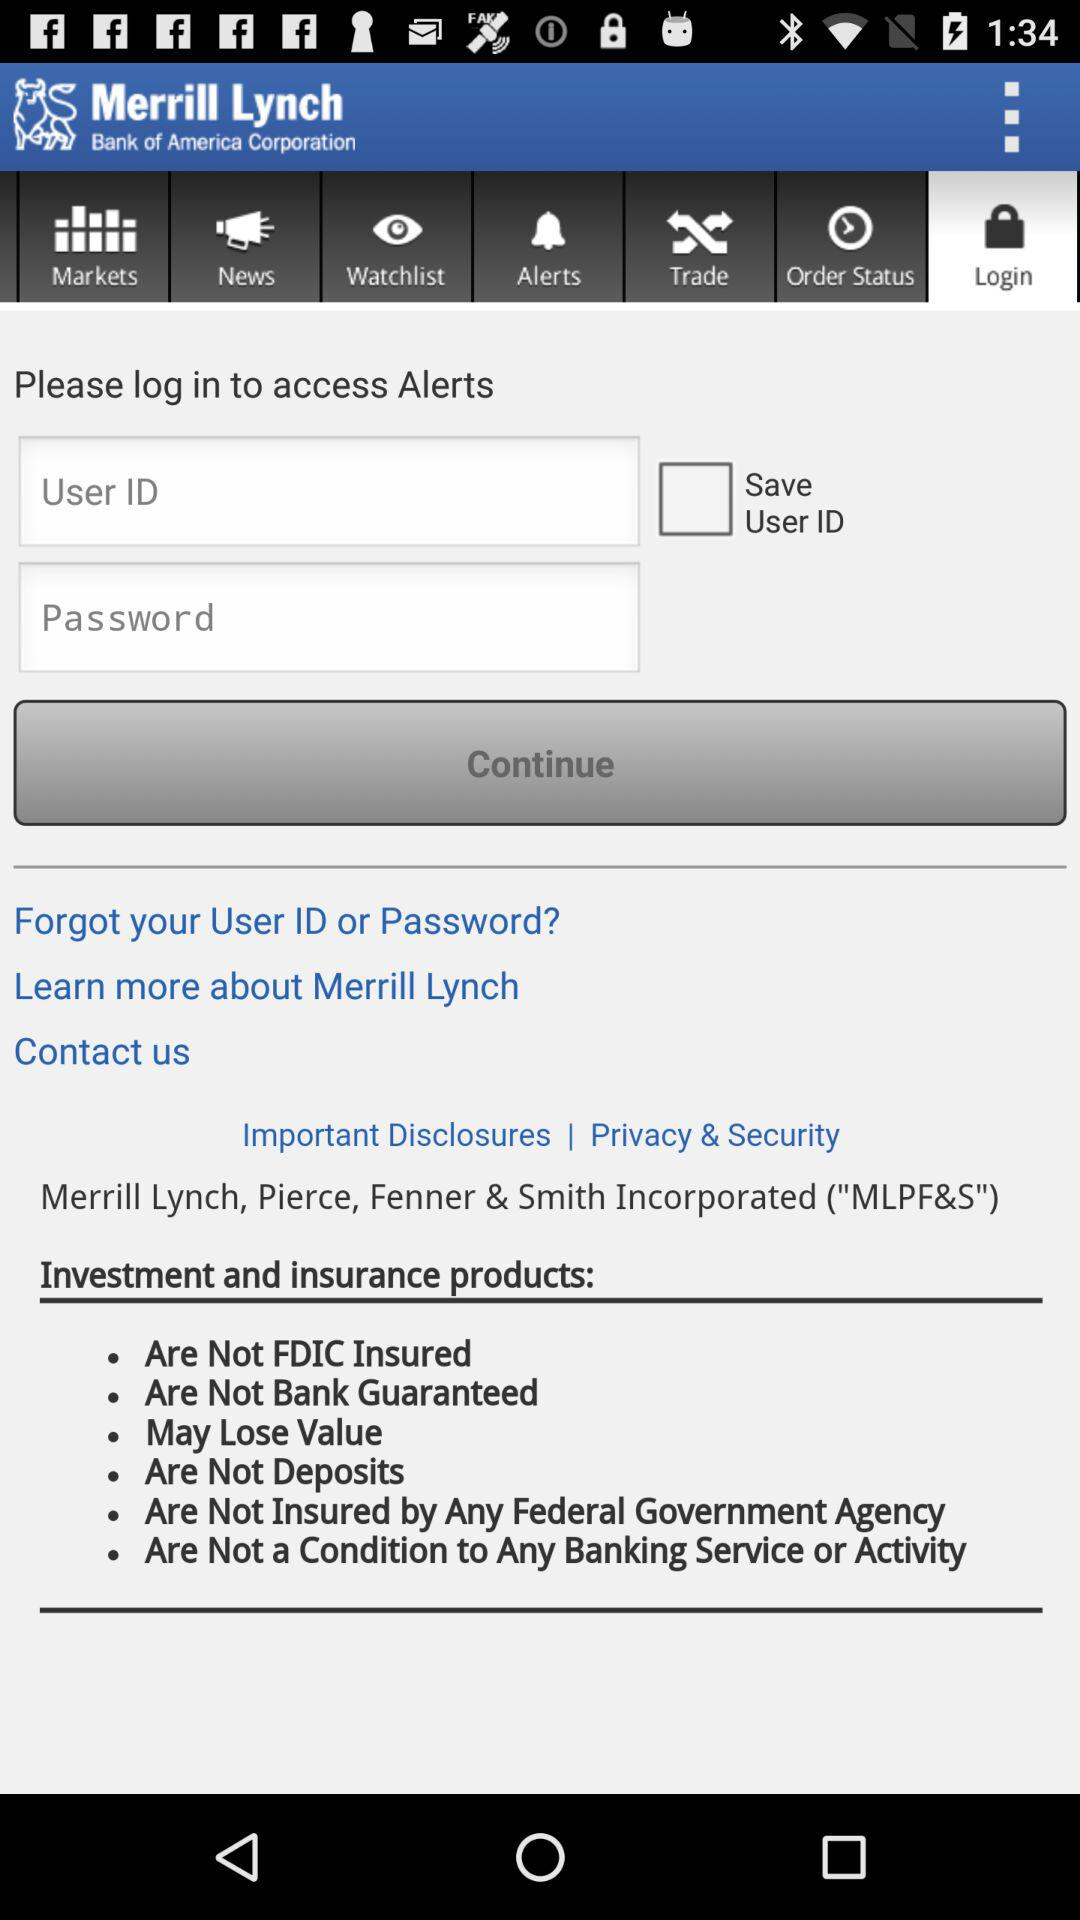What is the application name? The application name is "Merrill Lynch". 